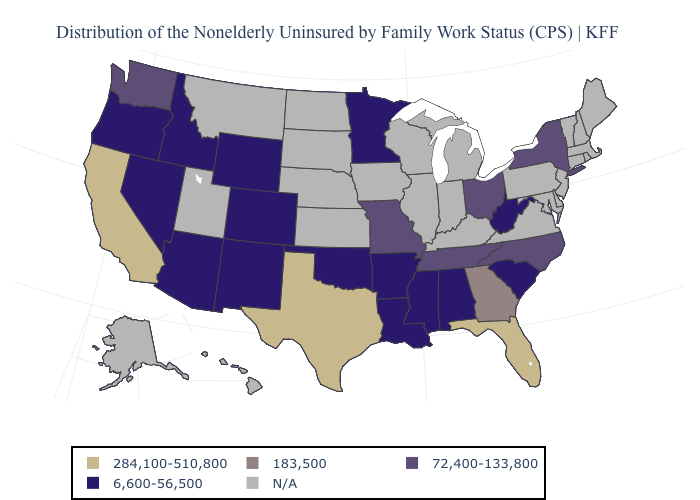What is the value of Utah?
Write a very short answer. N/A. What is the value of Nevada?
Short answer required. 6,600-56,500. What is the lowest value in the West?
Short answer required. 6,600-56,500. Name the states that have a value in the range 6,600-56,500?
Answer briefly. Alabama, Arizona, Arkansas, Colorado, Idaho, Louisiana, Minnesota, Mississippi, Nevada, New Mexico, Oklahoma, Oregon, South Carolina, West Virginia, Wyoming. Name the states that have a value in the range 72,400-133,800?
Short answer required. Missouri, New York, North Carolina, Ohio, Tennessee, Washington. What is the value of Texas?
Short answer required. 284,100-510,800. Which states have the lowest value in the USA?
Be succinct. Alabama, Arizona, Arkansas, Colorado, Idaho, Louisiana, Minnesota, Mississippi, Nevada, New Mexico, Oklahoma, Oregon, South Carolina, West Virginia, Wyoming. Among the states that border Iowa , does Minnesota have the lowest value?
Write a very short answer. Yes. What is the value of Utah?
Write a very short answer. N/A. Name the states that have a value in the range 6,600-56,500?
Write a very short answer. Alabama, Arizona, Arkansas, Colorado, Idaho, Louisiana, Minnesota, Mississippi, Nevada, New Mexico, Oklahoma, Oregon, South Carolina, West Virginia, Wyoming. What is the value of Connecticut?
Be succinct. N/A. Does Ohio have the lowest value in the USA?
Concise answer only. No. Does North Carolina have the lowest value in the USA?
Answer briefly. No. 